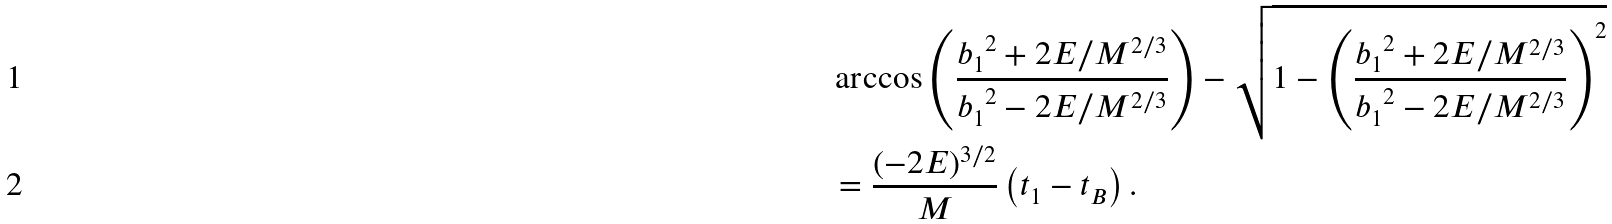<formula> <loc_0><loc_0><loc_500><loc_500>& \arccos \left ( \frac { { b _ { 1 } } ^ { 2 } + 2 E / M ^ { 2 / 3 } } { { b _ { 1 } } ^ { 2 } - 2 E / M ^ { 2 / 3 } } \right ) - \sqrt { 1 - \left ( \frac { { b _ { 1 } } ^ { 2 } + 2 E / M ^ { 2 / 3 } } { { b _ { 1 } } ^ { 2 } - 2 E / M ^ { 2 / 3 } } \right ) ^ { 2 } } \\ & = \frac { ( - 2 E ) ^ { 3 / 2 } } M \left ( t _ { 1 } - t _ { B } \right ) .</formula> 